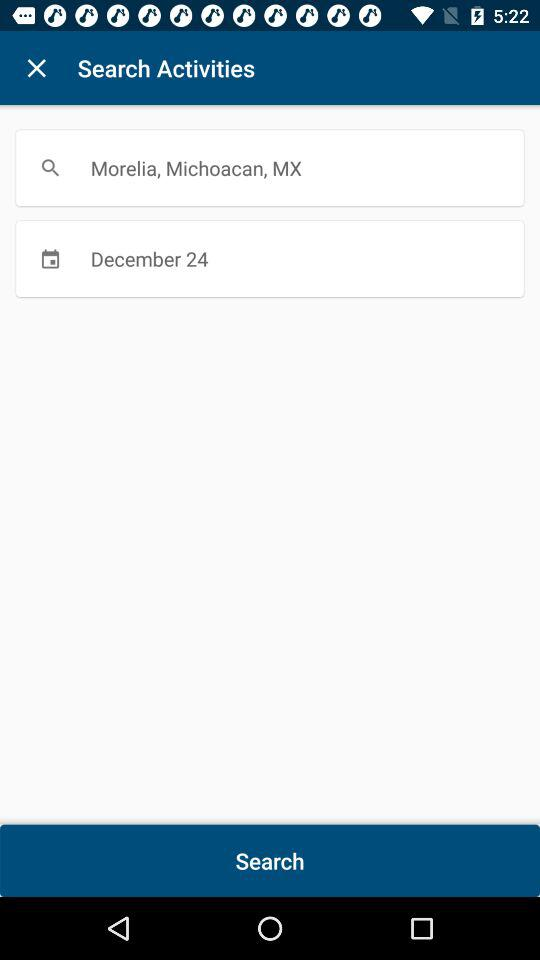What is the location input? The location input is Morelia, Michoacan, MX. 